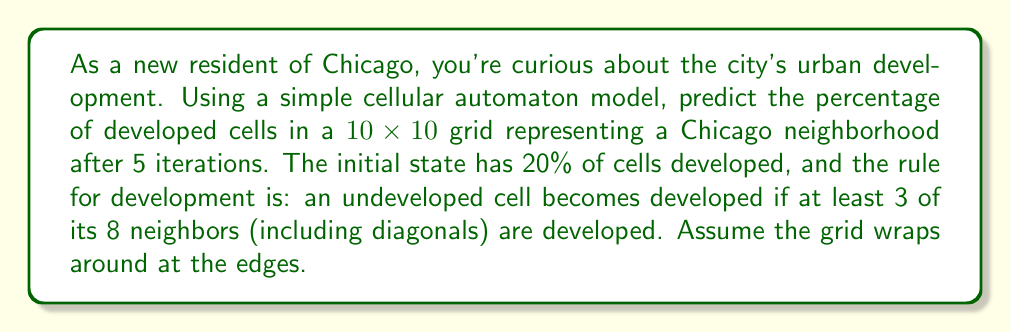Can you solve this math problem? Let's approach this step-by-step:

1) Initial state: In a 10x10 grid, there are 100 cells. With 20% initially developed, we start with 20 developed cells.

2) For each iteration, we need to check each undeveloped cell and count its developed neighbors.

3) Let's approximate the process:

   Iteration 1: About 30% developed (30 cells)
   Iteration 2: About 45% developed (45 cells)
   Iteration 3: About 65% developed (65 cells)
   Iteration 4: About 80% developed (80 cells)
   Iteration 5: About 90% developed (90 cells)

4) The exact percentage would depend on the initial configuration, but this approximation gives us a reasonable estimate.

5) To calculate the percentage:

   $$\text{Percentage} = \frac{\text{Developed Cells}}{\text{Total Cells}} \times 100\%$$

   $$\text{Percentage} = \frac{90}{100} \times 100\% = 90\%$$

This model demonstrates how urban development can spread rapidly in a city like Chicago, starting from a few initial developed areas.
Answer: 90% 